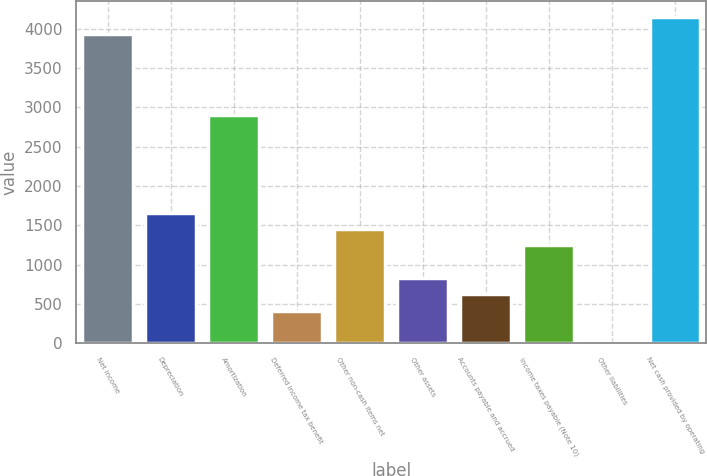Convert chart to OTSL. <chart><loc_0><loc_0><loc_500><loc_500><bar_chart><fcel>Net income<fcel>Depreciation<fcel>Amortization<fcel>Deferred income tax benefit<fcel>Other non-cash items net<fcel>Other assets<fcel>Accounts payable and accrued<fcel>Income taxes payable (Note 10)<fcel>Other liabilities<fcel>Net cash provided by operating<nl><fcel>3937.72<fcel>1658.74<fcel>2901.82<fcel>415.66<fcel>1451.56<fcel>830.02<fcel>622.84<fcel>1244.38<fcel>1.3<fcel>4144.9<nl></chart> 